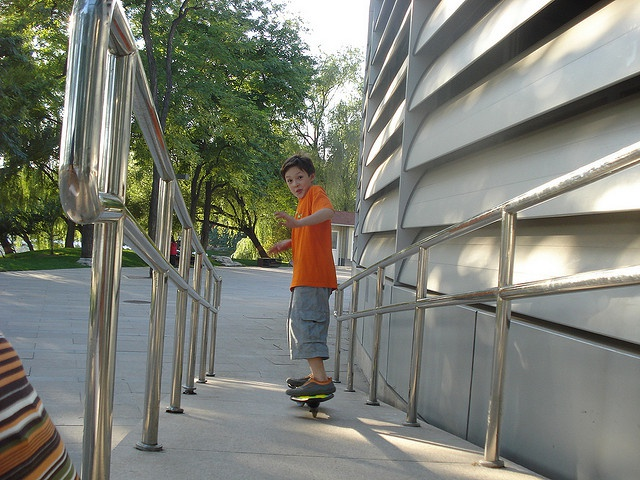Describe the objects in this image and their specific colors. I can see people in lightblue, gray, maroon, brown, and black tones, people in lightblue, black, maroon, and darkgray tones, skateboard in lightblue, black, gray, olive, and darkgreen tones, and people in lightblue, black, maroon, brown, and olive tones in this image. 